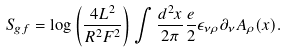<formula> <loc_0><loc_0><loc_500><loc_500>S _ { g f } = \log \left ( \frac { 4 L ^ { 2 } } { R ^ { 2 } F ^ { 2 } } \right ) \int \frac { d ^ { 2 } x } { 2 \pi } \frac { e } { 2 } \epsilon _ { \nu \rho } \partial _ { \nu } A _ { \rho } ( x ) .</formula> 